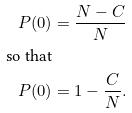Convert formula to latex. <formula><loc_0><loc_0><loc_500><loc_500>P ( 0 ) & = \frac { N - C } { N } \\ \text {so that} \\ P ( 0 ) & = 1 - \frac { C } { N } .</formula> 